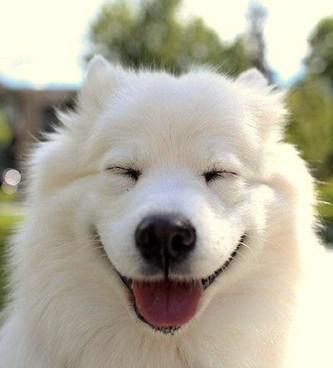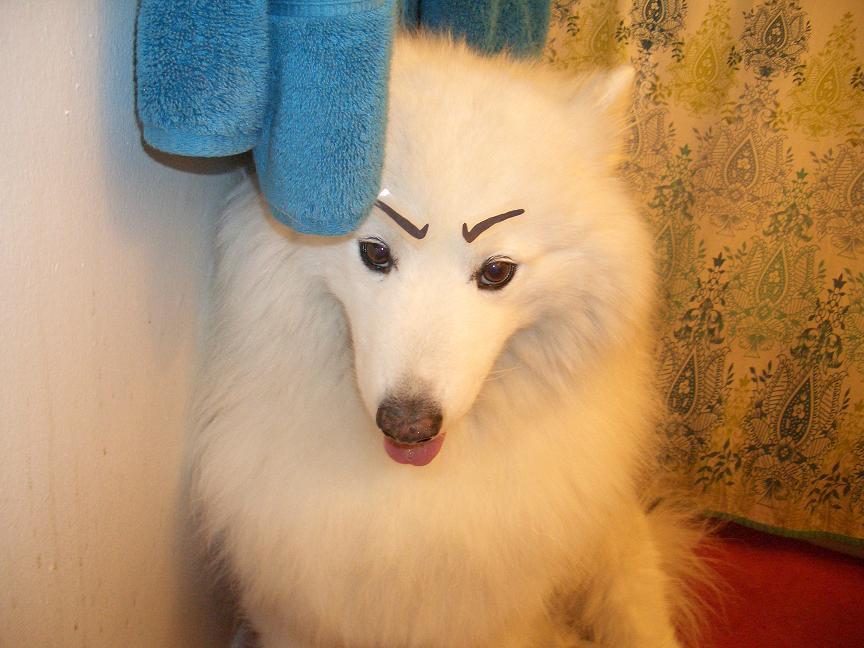The first image is the image on the left, the second image is the image on the right. Analyze the images presented: Is the assertion "An image shows an open-mouthed white dog with tongue showing and a non-fierce expression." valid? Answer yes or no. Yes. The first image is the image on the left, the second image is the image on the right. Assess this claim about the two images: "There's at least one angry dog showing its teeth in the image pair.". Correct or not? Answer yes or no. No. 